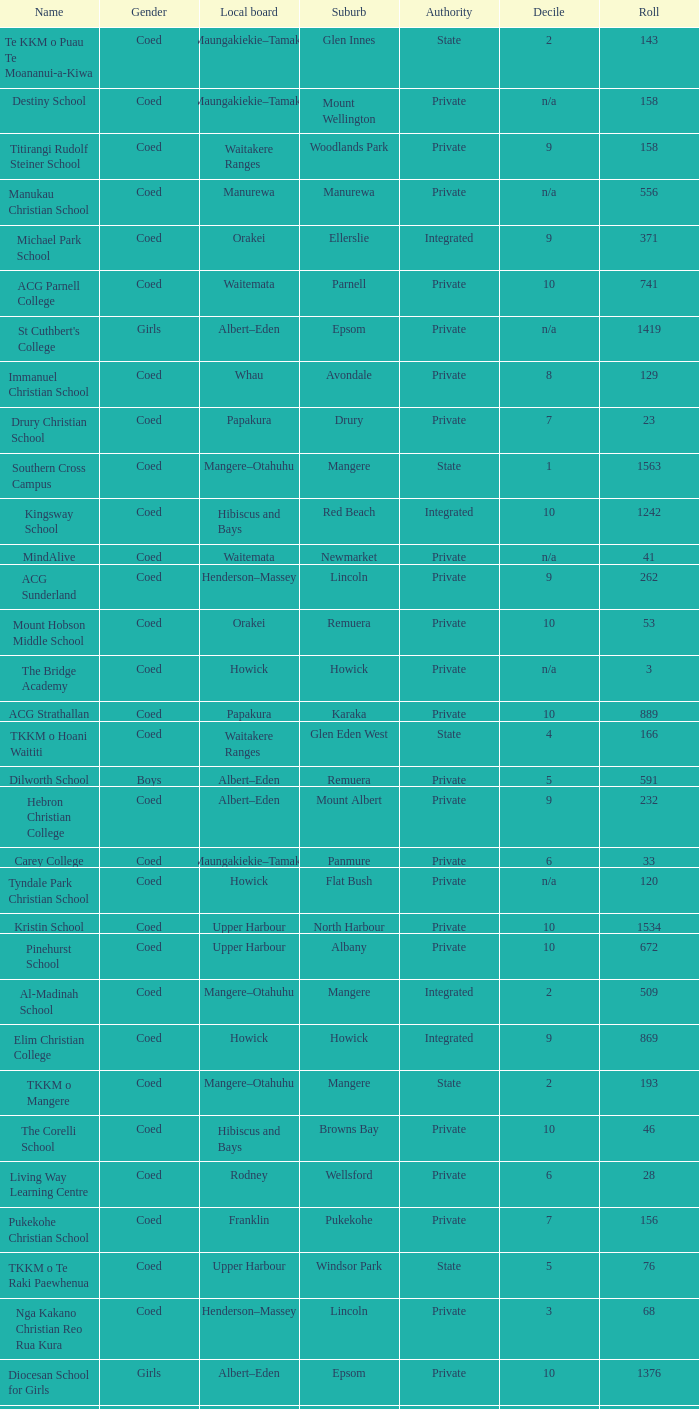What gender has a local board of albert–eden with a roll of more than 232 and Decile of 5? Boys. 